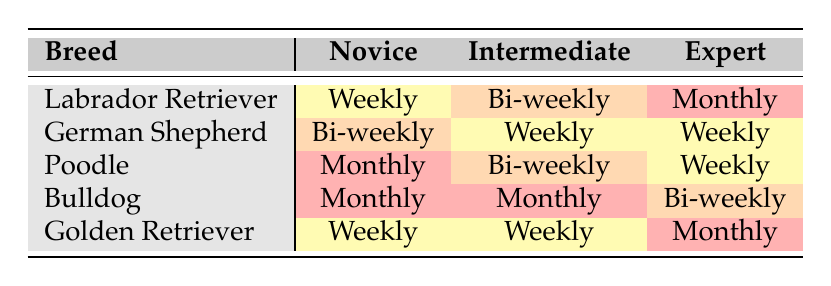What training frequency do novice owners typically use for Labrador Retrievers? In the table, under the "Labrador Retriever" row for "Novice," the training frequency listed is "Weekly."
Answer: Weekly Which breed has the highest frequency of monthly training among novice owners? Looking at the "Novice" column for all breeds, the "Poodle" and "Bulldog" both show "Monthly" as their training frequency. Since they are tied, they share the highest frequency of training among novice owners.
Answer: Poodle and Bulldog How many breeds have an expert owner training frequency listed as monthly? Examining the "Expert" column across all breeds, only the "Labrador Retriever," "Poodle," and "Golden Retriever" have a training frequency of "Monthly." However, "Bulldog" has "Bi-weekly," so the total is three breeds.
Answer: Three Is it true that all German Shepherd owners train their dogs weekly? In the "German Shepherd" row, for "Novice," the frequency is "Bi-weekly," indicating that not all German Shepherd owners train their dogs weekly.
Answer: No What is the difference in training frequency between novice and expert owners for Bulldogs? For Bulldogs, the novice training frequency is "Monthly," while the expert frequency is "Bi-weekly." "Monthly" is more frequent than "Bi-weekly," so the difference is one frequency level down.
Answer: One level down How does the training frequency for intermediate owners compare across all breeds? Checking the "Intermediate" column, we see that "Bi-weekly" for Poodles and Bulldogs and "Weekly" for Labrador and German Shepherds. Therefore, there are variations, with some having "Weekly" and others "Bi-weekly."
Answer: Variations in frequency Which breed has the most instances of weekly training across all owner experiences? Reviewing the table, both "Labrador Retriever" and "German Shepherd" breed show weekly training under novice and intermediate experiences. This gives a total of four "Weekly" instances spread across these two breeds.
Answer: Labrador Retriever and German Shepherd What is the training frequency for a novice owner of a Poodle? In the table, for "Poodle" under the "Novice" owner experience, the training frequency is "Monthly."
Answer: Monthly 